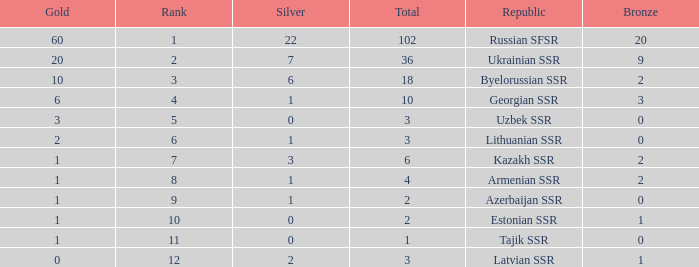What is the total number of bronzes associated with 1 silver, ranks under 6 and under 6 golds? None. 